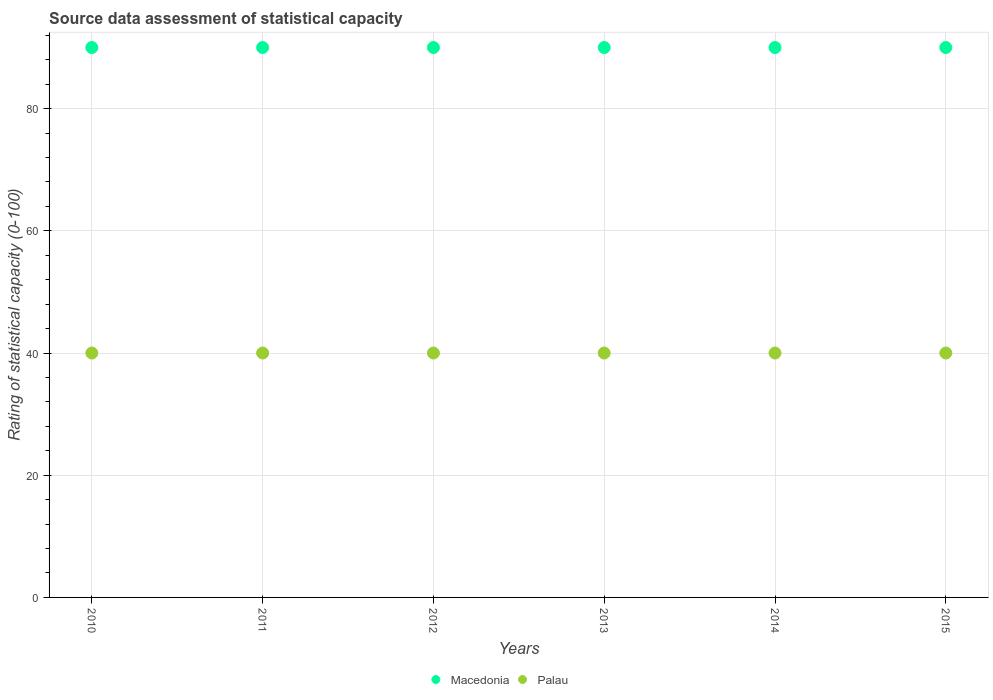How many different coloured dotlines are there?
Your response must be concise. 2. Is the number of dotlines equal to the number of legend labels?
Your answer should be very brief. Yes. What is the rating of statistical capacity in Macedonia in 2015?
Provide a succinct answer. 90. Across all years, what is the minimum rating of statistical capacity in Macedonia?
Offer a terse response. 90. In which year was the rating of statistical capacity in Palau maximum?
Your answer should be compact. 2010. In which year was the rating of statistical capacity in Palau minimum?
Your answer should be compact. 2010. What is the total rating of statistical capacity in Macedonia in the graph?
Your answer should be compact. 540. What is the difference between the rating of statistical capacity in Palau in 2011 and that in 2015?
Give a very brief answer. 0. What is the average rating of statistical capacity in Macedonia per year?
Offer a terse response. 90. In the year 2015, what is the difference between the rating of statistical capacity in Palau and rating of statistical capacity in Macedonia?
Give a very brief answer. -50. In how many years, is the rating of statistical capacity in Macedonia greater than 24?
Offer a very short reply. 6. Is the difference between the rating of statistical capacity in Palau in 2010 and 2012 greater than the difference between the rating of statistical capacity in Macedonia in 2010 and 2012?
Offer a very short reply. No. What is the difference between the highest and the second highest rating of statistical capacity in Palau?
Give a very brief answer. 0. In how many years, is the rating of statistical capacity in Palau greater than the average rating of statistical capacity in Palau taken over all years?
Your response must be concise. 0. Is the sum of the rating of statistical capacity in Macedonia in 2010 and 2013 greater than the maximum rating of statistical capacity in Palau across all years?
Your answer should be compact. Yes. How many years are there in the graph?
Make the answer very short. 6. What is the difference between two consecutive major ticks on the Y-axis?
Your answer should be very brief. 20. What is the title of the graph?
Provide a short and direct response. Source data assessment of statistical capacity. Does "Slovenia" appear as one of the legend labels in the graph?
Keep it short and to the point. No. What is the label or title of the X-axis?
Offer a terse response. Years. What is the label or title of the Y-axis?
Keep it short and to the point. Rating of statistical capacity (0-100). What is the Rating of statistical capacity (0-100) of Palau in 2010?
Make the answer very short. 40. What is the Rating of statistical capacity (0-100) of Macedonia in 2011?
Offer a very short reply. 90. What is the Rating of statistical capacity (0-100) in Palau in 2011?
Your response must be concise. 40. What is the Rating of statistical capacity (0-100) in Palau in 2012?
Make the answer very short. 40. What is the Rating of statistical capacity (0-100) of Macedonia in 2013?
Your answer should be very brief. 90. What is the Rating of statistical capacity (0-100) of Palau in 2014?
Provide a succinct answer. 40. What is the Rating of statistical capacity (0-100) of Macedonia in 2015?
Give a very brief answer. 90. What is the Rating of statistical capacity (0-100) in Palau in 2015?
Your answer should be compact. 40. Across all years, what is the maximum Rating of statistical capacity (0-100) of Palau?
Your answer should be compact. 40. Across all years, what is the minimum Rating of statistical capacity (0-100) of Macedonia?
Make the answer very short. 90. What is the total Rating of statistical capacity (0-100) of Macedonia in the graph?
Offer a terse response. 540. What is the total Rating of statistical capacity (0-100) of Palau in the graph?
Give a very brief answer. 240. What is the difference between the Rating of statistical capacity (0-100) of Palau in 2010 and that in 2011?
Your answer should be compact. 0. What is the difference between the Rating of statistical capacity (0-100) of Macedonia in 2010 and that in 2014?
Your response must be concise. 0. What is the difference between the Rating of statistical capacity (0-100) of Palau in 2010 and that in 2014?
Offer a terse response. 0. What is the difference between the Rating of statistical capacity (0-100) in Macedonia in 2010 and that in 2015?
Provide a short and direct response. 0. What is the difference between the Rating of statistical capacity (0-100) of Palau in 2010 and that in 2015?
Offer a terse response. 0. What is the difference between the Rating of statistical capacity (0-100) of Macedonia in 2011 and that in 2013?
Provide a short and direct response. 0. What is the difference between the Rating of statistical capacity (0-100) in Macedonia in 2012 and that in 2013?
Your answer should be compact. 0. What is the difference between the Rating of statistical capacity (0-100) of Macedonia in 2012 and that in 2014?
Provide a short and direct response. 0. What is the difference between the Rating of statistical capacity (0-100) of Macedonia in 2013 and that in 2014?
Make the answer very short. 0. What is the difference between the Rating of statistical capacity (0-100) in Palau in 2013 and that in 2014?
Provide a succinct answer. 0. What is the difference between the Rating of statistical capacity (0-100) of Macedonia in 2010 and the Rating of statistical capacity (0-100) of Palau in 2011?
Offer a terse response. 50. What is the difference between the Rating of statistical capacity (0-100) in Macedonia in 2010 and the Rating of statistical capacity (0-100) in Palau in 2013?
Ensure brevity in your answer.  50. What is the difference between the Rating of statistical capacity (0-100) of Macedonia in 2010 and the Rating of statistical capacity (0-100) of Palau in 2014?
Ensure brevity in your answer.  50. What is the difference between the Rating of statistical capacity (0-100) in Macedonia in 2011 and the Rating of statistical capacity (0-100) in Palau in 2012?
Offer a very short reply. 50. What is the difference between the Rating of statistical capacity (0-100) of Macedonia in 2011 and the Rating of statistical capacity (0-100) of Palau in 2013?
Give a very brief answer. 50. What is the difference between the Rating of statistical capacity (0-100) in Macedonia in 2011 and the Rating of statistical capacity (0-100) in Palau in 2015?
Your answer should be very brief. 50. What is the difference between the Rating of statistical capacity (0-100) of Macedonia in 2012 and the Rating of statistical capacity (0-100) of Palau in 2014?
Provide a succinct answer. 50. What is the average Rating of statistical capacity (0-100) in Macedonia per year?
Your response must be concise. 90. In the year 2013, what is the difference between the Rating of statistical capacity (0-100) in Macedonia and Rating of statistical capacity (0-100) in Palau?
Your answer should be very brief. 50. What is the ratio of the Rating of statistical capacity (0-100) in Palau in 2010 to that in 2011?
Your answer should be very brief. 1. What is the ratio of the Rating of statistical capacity (0-100) of Palau in 2010 to that in 2012?
Provide a succinct answer. 1. What is the ratio of the Rating of statistical capacity (0-100) in Palau in 2010 to that in 2013?
Ensure brevity in your answer.  1. What is the ratio of the Rating of statistical capacity (0-100) of Macedonia in 2010 to that in 2015?
Offer a very short reply. 1. What is the ratio of the Rating of statistical capacity (0-100) of Macedonia in 2011 to that in 2012?
Give a very brief answer. 1. What is the ratio of the Rating of statistical capacity (0-100) in Palau in 2011 to that in 2012?
Provide a succinct answer. 1. What is the ratio of the Rating of statistical capacity (0-100) in Macedonia in 2011 to that in 2013?
Offer a terse response. 1. What is the ratio of the Rating of statistical capacity (0-100) of Macedonia in 2011 to that in 2014?
Make the answer very short. 1. What is the ratio of the Rating of statistical capacity (0-100) of Macedonia in 2011 to that in 2015?
Your answer should be compact. 1. What is the ratio of the Rating of statistical capacity (0-100) in Palau in 2011 to that in 2015?
Keep it short and to the point. 1. What is the ratio of the Rating of statistical capacity (0-100) in Palau in 2012 to that in 2013?
Your response must be concise. 1. What is the ratio of the Rating of statistical capacity (0-100) of Palau in 2012 to that in 2014?
Your answer should be compact. 1. What is the ratio of the Rating of statistical capacity (0-100) in Macedonia in 2013 to that in 2014?
Keep it short and to the point. 1. What is the ratio of the Rating of statistical capacity (0-100) in Palau in 2013 to that in 2014?
Provide a succinct answer. 1. What is the ratio of the Rating of statistical capacity (0-100) in Macedonia in 2013 to that in 2015?
Offer a very short reply. 1. What is the ratio of the Rating of statistical capacity (0-100) in Macedonia in 2014 to that in 2015?
Offer a terse response. 1. What is the ratio of the Rating of statistical capacity (0-100) of Palau in 2014 to that in 2015?
Offer a very short reply. 1. What is the difference between the highest and the second highest Rating of statistical capacity (0-100) of Palau?
Your answer should be compact. 0. 